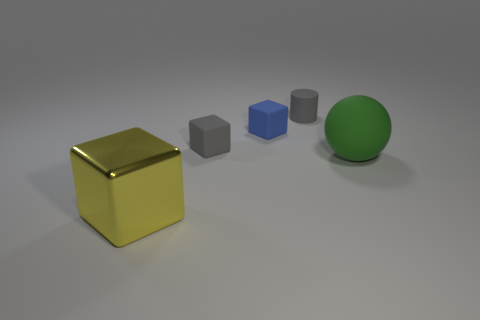Add 3 gray objects. How many objects exist? 8 Subtract all cubes. How many objects are left? 2 Subtract all blocks. Subtract all gray rubber objects. How many objects are left? 0 Add 4 big yellow things. How many big yellow things are left? 5 Add 1 large things. How many large things exist? 3 Subtract 0 brown blocks. How many objects are left? 5 